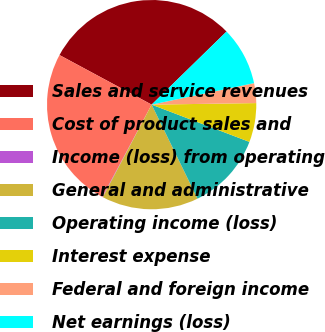Convert chart to OTSL. <chart><loc_0><loc_0><loc_500><loc_500><pie_chart><fcel>Sales and service revenues<fcel>Cost of product sales and<fcel>Income (loss) from operating<fcel>General and administrative<fcel>Operating income (loss)<fcel>Interest expense<fcel>Federal and foreign income<fcel>Net earnings (loss)<nl><fcel>29.84%<fcel>25.04%<fcel>0.08%<fcel>14.96%<fcel>11.98%<fcel>6.03%<fcel>3.06%<fcel>9.01%<nl></chart> 